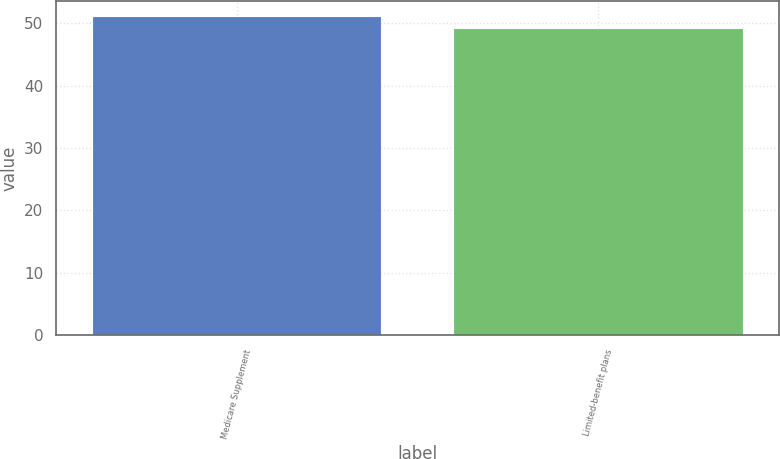Convert chart to OTSL. <chart><loc_0><loc_0><loc_500><loc_500><bar_chart><fcel>Medicare Supplement<fcel>Limited-benefit plans<nl><fcel>51<fcel>49<nl></chart> 